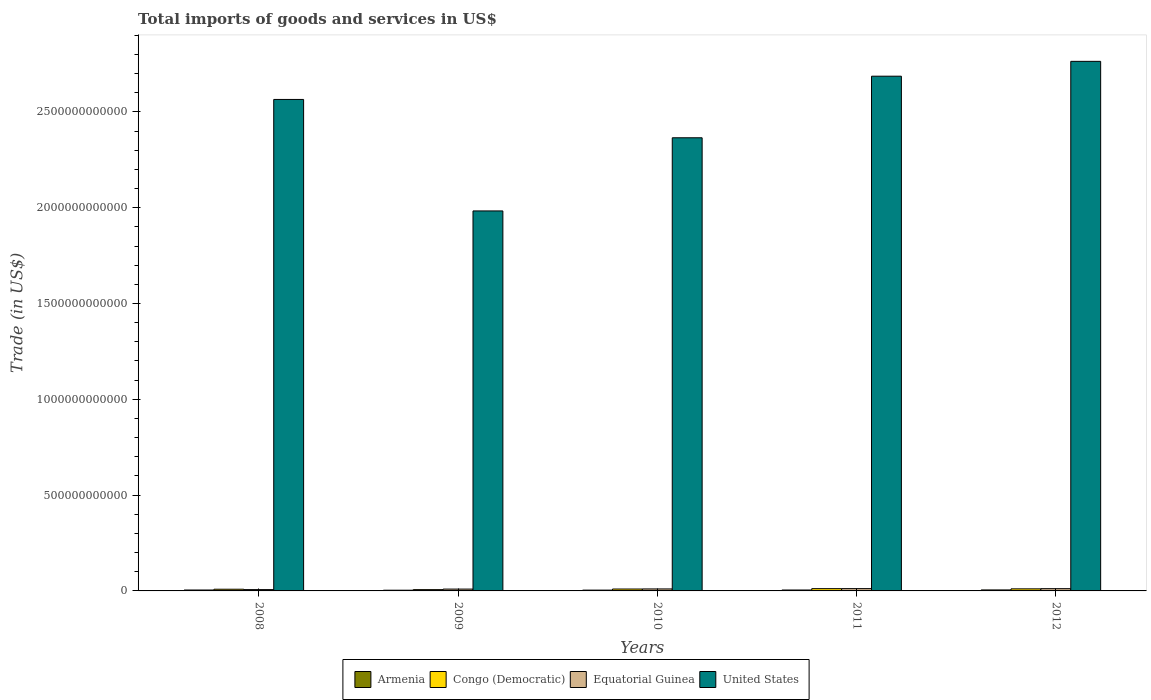How many groups of bars are there?
Offer a terse response. 5. Are the number of bars on each tick of the X-axis equal?
Keep it short and to the point. Yes. How many bars are there on the 2nd tick from the right?
Your response must be concise. 4. What is the total imports of goods and services in Congo (Democratic) in 2008?
Give a very brief answer. 8.85e+09. Across all years, what is the maximum total imports of goods and services in Equatorial Guinea?
Offer a very short reply. 1.20e+1. Across all years, what is the minimum total imports of goods and services in Equatorial Guinea?
Ensure brevity in your answer.  6.92e+09. In which year was the total imports of goods and services in Equatorial Guinea maximum?
Your answer should be very brief. 2011. What is the total total imports of goods and services in United States in the graph?
Ensure brevity in your answer.  1.24e+13. What is the difference between the total imports of goods and services in Armenia in 2011 and that in 2012?
Give a very brief answer. -3.37e+08. What is the difference between the total imports of goods and services in United States in 2011 and the total imports of goods and services in Congo (Democratic) in 2010?
Ensure brevity in your answer.  2.68e+12. What is the average total imports of goods and services in Congo (Democratic) per year?
Your answer should be very brief. 9.64e+09. In the year 2008, what is the difference between the total imports of goods and services in United States and total imports of goods and services in Armenia?
Offer a very short reply. 2.56e+12. What is the ratio of the total imports of goods and services in Congo (Democratic) in 2009 to that in 2012?
Keep it short and to the point. 0.62. Is the total imports of goods and services in Armenia in 2009 less than that in 2012?
Ensure brevity in your answer.  Yes. Is the difference between the total imports of goods and services in United States in 2008 and 2010 greater than the difference between the total imports of goods and services in Armenia in 2008 and 2010?
Offer a very short reply. Yes. What is the difference between the highest and the second highest total imports of goods and services in Congo (Democratic)?
Ensure brevity in your answer.  1.00e+09. What is the difference between the highest and the lowest total imports of goods and services in Congo (Democratic)?
Keep it short and to the point. 5.10e+09. In how many years, is the total imports of goods and services in United States greater than the average total imports of goods and services in United States taken over all years?
Provide a short and direct response. 3. Is the sum of the total imports of goods and services in Equatorial Guinea in 2008 and 2011 greater than the maximum total imports of goods and services in Armenia across all years?
Your answer should be very brief. Yes. What does the 4th bar from the left in 2012 represents?
Give a very brief answer. United States. Is it the case that in every year, the sum of the total imports of goods and services in Congo (Democratic) and total imports of goods and services in Armenia is greater than the total imports of goods and services in United States?
Ensure brevity in your answer.  No. How many years are there in the graph?
Your answer should be compact. 5. What is the difference between two consecutive major ticks on the Y-axis?
Provide a short and direct response. 5.00e+11. Does the graph contain grids?
Offer a very short reply. No. How are the legend labels stacked?
Your response must be concise. Horizontal. What is the title of the graph?
Give a very brief answer. Total imports of goods and services in US$. Does "Luxembourg" appear as one of the legend labels in the graph?
Your response must be concise. No. What is the label or title of the Y-axis?
Your answer should be compact. Trade (in US$). What is the Trade (in US$) of Armenia in 2008?
Your response must be concise. 4.74e+09. What is the Trade (in US$) of Congo (Democratic) in 2008?
Make the answer very short. 8.85e+09. What is the Trade (in US$) of Equatorial Guinea in 2008?
Give a very brief answer. 6.92e+09. What is the Trade (in US$) in United States in 2008?
Keep it short and to the point. 2.57e+12. What is the Trade (in US$) in Armenia in 2009?
Your answer should be compact. 3.72e+09. What is the Trade (in US$) in Congo (Democratic) in 2009?
Offer a terse response. 6.74e+09. What is the Trade (in US$) in Equatorial Guinea in 2009?
Provide a short and direct response. 9.54e+09. What is the Trade (in US$) of United States in 2009?
Make the answer very short. 1.98e+12. What is the Trade (in US$) of Armenia in 2010?
Keep it short and to the point. 4.20e+09. What is the Trade (in US$) of Congo (Democratic) in 2010?
Your answer should be compact. 9.94e+09. What is the Trade (in US$) in Equatorial Guinea in 2010?
Provide a succinct answer. 1.04e+1. What is the Trade (in US$) of United States in 2010?
Offer a terse response. 2.36e+12. What is the Trade (in US$) of Armenia in 2011?
Your answer should be compact. 4.80e+09. What is the Trade (in US$) of Congo (Democratic) in 2011?
Your answer should be compact. 1.18e+1. What is the Trade (in US$) of Equatorial Guinea in 2011?
Keep it short and to the point. 1.20e+1. What is the Trade (in US$) of United States in 2011?
Your answer should be compact. 2.69e+12. What is the Trade (in US$) in Armenia in 2012?
Keep it short and to the point. 5.14e+09. What is the Trade (in US$) in Congo (Democratic) in 2012?
Give a very brief answer. 1.08e+1. What is the Trade (in US$) in Equatorial Guinea in 2012?
Make the answer very short. 1.17e+1. What is the Trade (in US$) of United States in 2012?
Ensure brevity in your answer.  2.76e+12. Across all years, what is the maximum Trade (in US$) of Armenia?
Your answer should be compact. 5.14e+09. Across all years, what is the maximum Trade (in US$) of Congo (Democratic)?
Make the answer very short. 1.18e+1. Across all years, what is the maximum Trade (in US$) in Equatorial Guinea?
Your answer should be compact. 1.20e+1. Across all years, what is the maximum Trade (in US$) in United States?
Your answer should be compact. 2.76e+12. Across all years, what is the minimum Trade (in US$) in Armenia?
Give a very brief answer. 3.72e+09. Across all years, what is the minimum Trade (in US$) of Congo (Democratic)?
Your answer should be compact. 6.74e+09. Across all years, what is the minimum Trade (in US$) in Equatorial Guinea?
Keep it short and to the point. 6.92e+09. Across all years, what is the minimum Trade (in US$) of United States?
Your response must be concise. 1.98e+12. What is the total Trade (in US$) of Armenia in the graph?
Provide a succinct answer. 2.26e+1. What is the total Trade (in US$) of Congo (Democratic) in the graph?
Provide a succinct answer. 4.82e+1. What is the total Trade (in US$) in Equatorial Guinea in the graph?
Provide a succinct answer. 5.06e+1. What is the total Trade (in US$) in United States in the graph?
Keep it short and to the point. 1.24e+13. What is the difference between the Trade (in US$) of Armenia in 2008 and that in 2009?
Your answer should be very brief. 1.02e+09. What is the difference between the Trade (in US$) of Congo (Democratic) in 2008 and that in 2009?
Offer a terse response. 2.12e+09. What is the difference between the Trade (in US$) of Equatorial Guinea in 2008 and that in 2009?
Provide a succinct answer. -2.62e+09. What is the difference between the Trade (in US$) of United States in 2008 and that in 2009?
Provide a short and direct response. 5.82e+11. What is the difference between the Trade (in US$) of Armenia in 2008 and that in 2010?
Ensure brevity in your answer.  5.45e+08. What is the difference between the Trade (in US$) of Congo (Democratic) in 2008 and that in 2010?
Keep it short and to the point. -1.09e+09. What is the difference between the Trade (in US$) in Equatorial Guinea in 2008 and that in 2010?
Provide a succinct answer. -3.44e+09. What is the difference between the Trade (in US$) in United States in 2008 and that in 2010?
Your response must be concise. 2.00e+11. What is the difference between the Trade (in US$) of Armenia in 2008 and that in 2011?
Offer a very short reply. -6.14e+07. What is the difference between the Trade (in US$) in Congo (Democratic) in 2008 and that in 2011?
Give a very brief answer. -2.99e+09. What is the difference between the Trade (in US$) in Equatorial Guinea in 2008 and that in 2011?
Give a very brief answer. -5.09e+09. What is the difference between the Trade (in US$) in United States in 2008 and that in 2011?
Ensure brevity in your answer.  -1.21e+11. What is the difference between the Trade (in US$) in Armenia in 2008 and that in 2012?
Give a very brief answer. -3.98e+08. What is the difference between the Trade (in US$) of Congo (Democratic) in 2008 and that in 2012?
Your response must be concise. -1.99e+09. What is the difference between the Trade (in US$) in Equatorial Guinea in 2008 and that in 2012?
Your answer should be compact. -4.82e+09. What is the difference between the Trade (in US$) in United States in 2008 and that in 2012?
Your answer should be very brief. -1.99e+11. What is the difference between the Trade (in US$) of Armenia in 2009 and that in 2010?
Provide a short and direct response. -4.78e+08. What is the difference between the Trade (in US$) of Congo (Democratic) in 2009 and that in 2010?
Provide a short and direct response. -3.20e+09. What is the difference between the Trade (in US$) in Equatorial Guinea in 2009 and that in 2010?
Your answer should be very brief. -8.16e+08. What is the difference between the Trade (in US$) in United States in 2009 and that in 2010?
Offer a very short reply. -3.82e+11. What is the difference between the Trade (in US$) of Armenia in 2009 and that in 2011?
Provide a succinct answer. -1.08e+09. What is the difference between the Trade (in US$) of Congo (Democratic) in 2009 and that in 2011?
Your response must be concise. -5.10e+09. What is the difference between the Trade (in US$) in Equatorial Guinea in 2009 and that in 2011?
Ensure brevity in your answer.  -2.47e+09. What is the difference between the Trade (in US$) of United States in 2009 and that in 2011?
Offer a very short reply. -7.03e+11. What is the difference between the Trade (in US$) in Armenia in 2009 and that in 2012?
Offer a very short reply. -1.42e+09. What is the difference between the Trade (in US$) of Congo (Democratic) in 2009 and that in 2012?
Your answer should be very brief. -4.10e+09. What is the difference between the Trade (in US$) in Equatorial Guinea in 2009 and that in 2012?
Offer a very short reply. -2.20e+09. What is the difference between the Trade (in US$) in United States in 2009 and that in 2012?
Offer a terse response. -7.81e+11. What is the difference between the Trade (in US$) in Armenia in 2010 and that in 2011?
Your answer should be very brief. -6.06e+08. What is the difference between the Trade (in US$) of Congo (Democratic) in 2010 and that in 2011?
Your answer should be compact. -1.90e+09. What is the difference between the Trade (in US$) in Equatorial Guinea in 2010 and that in 2011?
Give a very brief answer. -1.65e+09. What is the difference between the Trade (in US$) in United States in 2010 and that in 2011?
Give a very brief answer. -3.21e+11. What is the difference between the Trade (in US$) of Armenia in 2010 and that in 2012?
Keep it short and to the point. -9.43e+08. What is the difference between the Trade (in US$) of Congo (Democratic) in 2010 and that in 2012?
Ensure brevity in your answer.  -8.99e+08. What is the difference between the Trade (in US$) of Equatorial Guinea in 2010 and that in 2012?
Your response must be concise. -1.39e+09. What is the difference between the Trade (in US$) of United States in 2010 and that in 2012?
Offer a terse response. -3.99e+11. What is the difference between the Trade (in US$) of Armenia in 2011 and that in 2012?
Provide a succinct answer. -3.37e+08. What is the difference between the Trade (in US$) of Congo (Democratic) in 2011 and that in 2012?
Your response must be concise. 1.00e+09. What is the difference between the Trade (in US$) in Equatorial Guinea in 2011 and that in 2012?
Your answer should be very brief. 2.66e+08. What is the difference between the Trade (in US$) of United States in 2011 and that in 2012?
Offer a terse response. -7.75e+1. What is the difference between the Trade (in US$) of Armenia in 2008 and the Trade (in US$) of Congo (Democratic) in 2009?
Provide a succinct answer. -2.00e+09. What is the difference between the Trade (in US$) in Armenia in 2008 and the Trade (in US$) in Equatorial Guinea in 2009?
Provide a succinct answer. -4.80e+09. What is the difference between the Trade (in US$) of Armenia in 2008 and the Trade (in US$) of United States in 2009?
Ensure brevity in your answer.  -1.98e+12. What is the difference between the Trade (in US$) of Congo (Democratic) in 2008 and the Trade (in US$) of Equatorial Guinea in 2009?
Provide a short and direct response. -6.85e+08. What is the difference between the Trade (in US$) of Congo (Democratic) in 2008 and the Trade (in US$) of United States in 2009?
Make the answer very short. -1.97e+12. What is the difference between the Trade (in US$) of Equatorial Guinea in 2008 and the Trade (in US$) of United States in 2009?
Give a very brief answer. -1.98e+12. What is the difference between the Trade (in US$) of Armenia in 2008 and the Trade (in US$) of Congo (Democratic) in 2010?
Provide a short and direct response. -5.20e+09. What is the difference between the Trade (in US$) in Armenia in 2008 and the Trade (in US$) in Equatorial Guinea in 2010?
Offer a terse response. -5.61e+09. What is the difference between the Trade (in US$) in Armenia in 2008 and the Trade (in US$) in United States in 2010?
Your answer should be very brief. -2.36e+12. What is the difference between the Trade (in US$) of Congo (Democratic) in 2008 and the Trade (in US$) of Equatorial Guinea in 2010?
Your answer should be very brief. -1.50e+09. What is the difference between the Trade (in US$) in Congo (Democratic) in 2008 and the Trade (in US$) in United States in 2010?
Offer a terse response. -2.36e+12. What is the difference between the Trade (in US$) of Equatorial Guinea in 2008 and the Trade (in US$) of United States in 2010?
Offer a very short reply. -2.36e+12. What is the difference between the Trade (in US$) of Armenia in 2008 and the Trade (in US$) of Congo (Democratic) in 2011?
Ensure brevity in your answer.  -7.10e+09. What is the difference between the Trade (in US$) in Armenia in 2008 and the Trade (in US$) in Equatorial Guinea in 2011?
Provide a short and direct response. -7.27e+09. What is the difference between the Trade (in US$) of Armenia in 2008 and the Trade (in US$) of United States in 2011?
Keep it short and to the point. -2.68e+12. What is the difference between the Trade (in US$) of Congo (Democratic) in 2008 and the Trade (in US$) of Equatorial Guinea in 2011?
Offer a very short reply. -3.16e+09. What is the difference between the Trade (in US$) in Congo (Democratic) in 2008 and the Trade (in US$) in United States in 2011?
Ensure brevity in your answer.  -2.68e+12. What is the difference between the Trade (in US$) of Equatorial Guinea in 2008 and the Trade (in US$) of United States in 2011?
Your answer should be compact. -2.68e+12. What is the difference between the Trade (in US$) of Armenia in 2008 and the Trade (in US$) of Congo (Democratic) in 2012?
Offer a very short reply. -6.10e+09. What is the difference between the Trade (in US$) in Armenia in 2008 and the Trade (in US$) in Equatorial Guinea in 2012?
Provide a short and direct response. -7.00e+09. What is the difference between the Trade (in US$) in Armenia in 2008 and the Trade (in US$) in United States in 2012?
Ensure brevity in your answer.  -2.76e+12. What is the difference between the Trade (in US$) of Congo (Democratic) in 2008 and the Trade (in US$) of Equatorial Guinea in 2012?
Make the answer very short. -2.89e+09. What is the difference between the Trade (in US$) of Congo (Democratic) in 2008 and the Trade (in US$) of United States in 2012?
Your response must be concise. -2.75e+12. What is the difference between the Trade (in US$) in Equatorial Guinea in 2008 and the Trade (in US$) in United States in 2012?
Provide a succinct answer. -2.76e+12. What is the difference between the Trade (in US$) in Armenia in 2009 and the Trade (in US$) in Congo (Democratic) in 2010?
Provide a short and direct response. -6.22e+09. What is the difference between the Trade (in US$) in Armenia in 2009 and the Trade (in US$) in Equatorial Guinea in 2010?
Make the answer very short. -6.64e+09. What is the difference between the Trade (in US$) of Armenia in 2009 and the Trade (in US$) of United States in 2010?
Make the answer very short. -2.36e+12. What is the difference between the Trade (in US$) of Congo (Democratic) in 2009 and the Trade (in US$) of Equatorial Guinea in 2010?
Make the answer very short. -3.62e+09. What is the difference between the Trade (in US$) in Congo (Democratic) in 2009 and the Trade (in US$) in United States in 2010?
Ensure brevity in your answer.  -2.36e+12. What is the difference between the Trade (in US$) of Equatorial Guinea in 2009 and the Trade (in US$) of United States in 2010?
Give a very brief answer. -2.36e+12. What is the difference between the Trade (in US$) of Armenia in 2009 and the Trade (in US$) of Congo (Democratic) in 2011?
Your answer should be very brief. -8.12e+09. What is the difference between the Trade (in US$) in Armenia in 2009 and the Trade (in US$) in Equatorial Guinea in 2011?
Ensure brevity in your answer.  -8.29e+09. What is the difference between the Trade (in US$) in Armenia in 2009 and the Trade (in US$) in United States in 2011?
Offer a very short reply. -2.68e+12. What is the difference between the Trade (in US$) of Congo (Democratic) in 2009 and the Trade (in US$) of Equatorial Guinea in 2011?
Offer a terse response. -5.27e+09. What is the difference between the Trade (in US$) of Congo (Democratic) in 2009 and the Trade (in US$) of United States in 2011?
Keep it short and to the point. -2.68e+12. What is the difference between the Trade (in US$) in Equatorial Guinea in 2009 and the Trade (in US$) in United States in 2011?
Your response must be concise. -2.68e+12. What is the difference between the Trade (in US$) in Armenia in 2009 and the Trade (in US$) in Congo (Democratic) in 2012?
Your answer should be compact. -7.12e+09. What is the difference between the Trade (in US$) of Armenia in 2009 and the Trade (in US$) of Equatorial Guinea in 2012?
Provide a succinct answer. -8.02e+09. What is the difference between the Trade (in US$) in Armenia in 2009 and the Trade (in US$) in United States in 2012?
Offer a very short reply. -2.76e+12. What is the difference between the Trade (in US$) of Congo (Democratic) in 2009 and the Trade (in US$) of Equatorial Guinea in 2012?
Keep it short and to the point. -5.01e+09. What is the difference between the Trade (in US$) in Congo (Democratic) in 2009 and the Trade (in US$) in United States in 2012?
Your response must be concise. -2.76e+12. What is the difference between the Trade (in US$) of Equatorial Guinea in 2009 and the Trade (in US$) of United States in 2012?
Your answer should be very brief. -2.75e+12. What is the difference between the Trade (in US$) of Armenia in 2010 and the Trade (in US$) of Congo (Democratic) in 2011?
Make the answer very short. -7.64e+09. What is the difference between the Trade (in US$) in Armenia in 2010 and the Trade (in US$) in Equatorial Guinea in 2011?
Provide a succinct answer. -7.81e+09. What is the difference between the Trade (in US$) of Armenia in 2010 and the Trade (in US$) of United States in 2011?
Your answer should be very brief. -2.68e+12. What is the difference between the Trade (in US$) in Congo (Democratic) in 2010 and the Trade (in US$) in Equatorial Guinea in 2011?
Give a very brief answer. -2.07e+09. What is the difference between the Trade (in US$) in Congo (Democratic) in 2010 and the Trade (in US$) in United States in 2011?
Your answer should be very brief. -2.68e+12. What is the difference between the Trade (in US$) of Equatorial Guinea in 2010 and the Trade (in US$) of United States in 2011?
Your response must be concise. -2.68e+12. What is the difference between the Trade (in US$) of Armenia in 2010 and the Trade (in US$) of Congo (Democratic) in 2012?
Provide a succinct answer. -6.64e+09. What is the difference between the Trade (in US$) in Armenia in 2010 and the Trade (in US$) in Equatorial Guinea in 2012?
Offer a terse response. -7.55e+09. What is the difference between the Trade (in US$) of Armenia in 2010 and the Trade (in US$) of United States in 2012?
Ensure brevity in your answer.  -2.76e+12. What is the difference between the Trade (in US$) of Congo (Democratic) in 2010 and the Trade (in US$) of Equatorial Guinea in 2012?
Offer a very short reply. -1.80e+09. What is the difference between the Trade (in US$) in Congo (Democratic) in 2010 and the Trade (in US$) in United States in 2012?
Keep it short and to the point. -2.75e+12. What is the difference between the Trade (in US$) in Equatorial Guinea in 2010 and the Trade (in US$) in United States in 2012?
Ensure brevity in your answer.  -2.75e+12. What is the difference between the Trade (in US$) of Armenia in 2011 and the Trade (in US$) of Congo (Democratic) in 2012?
Provide a succinct answer. -6.04e+09. What is the difference between the Trade (in US$) in Armenia in 2011 and the Trade (in US$) in Equatorial Guinea in 2012?
Ensure brevity in your answer.  -6.94e+09. What is the difference between the Trade (in US$) in Armenia in 2011 and the Trade (in US$) in United States in 2012?
Offer a terse response. -2.76e+12. What is the difference between the Trade (in US$) in Congo (Democratic) in 2011 and the Trade (in US$) in Equatorial Guinea in 2012?
Your answer should be very brief. 9.64e+07. What is the difference between the Trade (in US$) of Congo (Democratic) in 2011 and the Trade (in US$) of United States in 2012?
Provide a short and direct response. -2.75e+12. What is the difference between the Trade (in US$) in Equatorial Guinea in 2011 and the Trade (in US$) in United States in 2012?
Keep it short and to the point. -2.75e+12. What is the average Trade (in US$) in Armenia per year?
Ensure brevity in your answer.  4.52e+09. What is the average Trade (in US$) in Congo (Democratic) per year?
Your answer should be compact. 9.64e+09. What is the average Trade (in US$) in Equatorial Guinea per year?
Provide a succinct answer. 1.01e+1. What is the average Trade (in US$) of United States per year?
Make the answer very short. 2.47e+12. In the year 2008, what is the difference between the Trade (in US$) in Armenia and Trade (in US$) in Congo (Democratic)?
Give a very brief answer. -4.11e+09. In the year 2008, what is the difference between the Trade (in US$) of Armenia and Trade (in US$) of Equatorial Guinea?
Offer a very short reply. -2.18e+09. In the year 2008, what is the difference between the Trade (in US$) of Armenia and Trade (in US$) of United States?
Provide a short and direct response. -2.56e+12. In the year 2008, what is the difference between the Trade (in US$) of Congo (Democratic) and Trade (in US$) of Equatorial Guinea?
Offer a terse response. 1.94e+09. In the year 2008, what is the difference between the Trade (in US$) of Congo (Democratic) and Trade (in US$) of United States?
Provide a succinct answer. -2.56e+12. In the year 2008, what is the difference between the Trade (in US$) in Equatorial Guinea and Trade (in US$) in United States?
Give a very brief answer. -2.56e+12. In the year 2009, what is the difference between the Trade (in US$) of Armenia and Trade (in US$) of Congo (Democratic)?
Your answer should be very brief. -3.02e+09. In the year 2009, what is the difference between the Trade (in US$) in Armenia and Trade (in US$) in Equatorial Guinea?
Make the answer very short. -5.82e+09. In the year 2009, what is the difference between the Trade (in US$) in Armenia and Trade (in US$) in United States?
Your answer should be very brief. -1.98e+12. In the year 2009, what is the difference between the Trade (in US$) in Congo (Democratic) and Trade (in US$) in Equatorial Guinea?
Provide a succinct answer. -2.80e+09. In the year 2009, what is the difference between the Trade (in US$) of Congo (Democratic) and Trade (in US$) of United States?
Ensure brevity in your answer.  -1.98e+12. In the year 2009, what is the difference between the Trade (in US$) in Equatorial Guinea and Trade (in US$) in United States?
Your answer should be very brief. -1.97e+12. In the year 2010, what is the difference between the Trade (in US$) of Armenia and Trade (in US$) of Congo (Democratic)?
Your response must be concise. -5.74e+09. In the year 2010, what is the difference between the Trade (in US$) in Armenia and Trade (in US$) in Equatorial Guinea?
Provide a succinct answer. -6.16e+09. In the year 2010, what is the difference between the Trade (in US$) in Armenia and Trade (in US$) in United States?
Provide a short and direct response. -2.36e+12. In the year 2010, what is the difference between the Trade (in US$) in Congo (Democratic) and Trade (in US$) in Equatorial Guinea?
Your answer should be compact. -4.15e+08. In the year 2010, what is the difference between the Trade (in US$) of Congo (Democratic) and Trade (in US$) of United States?
Your answer should be compact. -2.36e+12. In the year 2010, what is the difference between the Trade (in US$) in Equatorial Guinea and Trade (in US$) in United States?
Your answer should be compact. -2.35e+12. In the year 2011, what is the difference between the Trade (in US$) in Armenia and Trade (in US$) in Congo (Democratic)?
Make the answer very short. -7.04e+09. In the year 2011, what is the difference between the Trade (in US$) in Armenia and Trade (in US$) in Equatorial Guinea?
Your answer should be very brief. -7.21e+09. In the year 2011, what is the difference between the Trade (in US$) in Armenia and Trade (in US$) in United States?
Provide a succinct answer. -2.68e+12. In the year 2011, what is the difference between the Trade (in US$) of Congo (Democratic) and Trade (in US$) of Equatorial Guinea?
Make the answer very short. -1.70e+08. In the year 2011, what is the difference between the Trade (in US$) in Congo (Democratic) and Trade (in US$) in United States?
Give a very brief answer. -2.67e+12. In the year 2011, what is the difference between the Trade (in US$) in Equatorial Guinea and Trade (in US$) in United States?
Ensure brevity in your answer.  -2.67e+12. In the year 2012, what is the difference between the Trade (in US$) in Armenia and Trade (in US$) in Congo (Democratic)?
Give a very brief answer. -5.70e+09. In the year 2012, what is the difference between the Trade (in US$) in Armenia and Trade (in US$) in Equatorial Guinea?
Offer a very short reply. -6.60e+09. In the year 2012, what is the difference between the Trade (in US$) of Armenia and Trade (in US$) of United States?
Make the answer very short. -2.76e+12. In the year 2012, what is the difference between the Trade (in US$) in Congo (Democratic) and Trade (in US$) in Equatorial Guinea?
Offer a very short reply. -9.03e+08. In the year 2012, what is the difference between the Trade (in US$) in Congo (Democratic) and Trade (in US$) in United States?
Make the answer very short. -2.75e+12. In the year 2012, what is the difference between the Trade (in US$) in Equatorial Guinea and Trade (in US$) in United States?
Your response must be concise. -2.75e+12. What is the ratio of the Trade (in US$) in Armenia in 2008 to that in 2009?
Provide a succinct answer. 1.27. What is the ratio of the Trade (in US$) of Congo (Democratic) in 2008 to that in 2009?
Offer a very short reply. 1.31. What is the ratio of the Trade (in US$) in Equatorial Guinea in 2008 to that in 2009?
Your response must be concise. 0.73. What is the ratio of the Trade (in US$) of United States in 2008 to that in 2009?
Offer a terse response. 1.29. What is the ratio of the Trade (in US$) of Armenia in 2008 to that in 2010?
Provide a succinct answer. 1.13. What is the ratio of the Trade (in US$) in Congo (Democratic) in 2008 to that in 2010?
Provide a succinct answer. 0.89. What is the ratio of the Trade (in US$) in Equatorial Guinea in 2008 to that in 2010?
Offer a terse response. 0.67. What is the ratio of the Trade (in US$) of United States in 2008 to that in 2010?
Offer a terse response. 1.08. What is the ratio of the Trade (in US$) of Armenia in 2008 to that in 2011?
Your answer should be very brief. 0.99. What is the ratio of the Trade (in US$) in Congo (Democratic) in 2008 to that in 2011?
Your answer should be very brief. 0.75. What is the ratio of the Trade (in US$) of Equatorial Guinea in 2008 to that in 2011?
Your answer should be compact. 0.58. What is the ratio of the Trade (in US$) of United States in 2008 to that in 2011?
Keep it short and to the point. 0.95. What is the ratio of the Trade (in US$) in Armenia in 2008 to that in 2012?
Give a very brief answer. 0.92. What is the ratio of the Trade (in US$) in Congo (Democratic) in 2008 to that in 2012?
Offer a terse response. 0.82. What is the ratio of the Trade (in US$) in Equatorial Guinea in 2008 to that in 2012?
Keep it short and to the point. 0.59. What is the ratio of the Trade (in US$) of United States in 2008 to that in 2012?
Your answer should be compact. 0.93. What is the ratio of the Trade (in US$) in Armenia in 2009 to that in 2010?
Make the answer very short. 0.89. What is the ratio of the Trade (in US$) in Congo (Democratic) in 2009 to that in 2010?
Provide a succinct answer. 0.68. What is the ratio of the Trade (in US$) in Equatorial Guinea in 2009 to that in 2010?
Your answer should be compact. 0.92. What is the ratio of the Trade (in US$) in United States in 2009 to that in 2010?
Your answer should be very brief. 0.84. What is the ratio of the Trade (in US$) of Armenia in 2009 to that in 2011?
Offer a terse response. 0.77. What is the ratio of the Trade (in US$) of Congo (Democratic) in 2009 to that in 2011?
Provide a succinct answer. 0.57. What is the ratio of the Trade (in US$) of Equatorial Guinea in 2009 to that in 2011?
Your answer should be compact. 0.79. What is the ratio of the Trade (in US$) in United States in 2009 to that in 2011?
Provide a succinct answer. 0.74. What is the ratio of the Trade (in US$) in Armenia in 2009 to that in 2012?
Your answer should be compact. 0.72. What is the ratio of the Trade (in US$) of Congo (Democratic) in 2009 to that in 2012?
Provide a short and direct response. 0.62. What is the ratio of the Trade (in US$) in Equatorial Guinea in 2009 to that in 2012?
Give a very brief answer. 0.81. What is the ratio of the Trade (in US$) in United States in 2009 to that in 2012?
Provide a succinct answer. 0.72. What is the ratio of the Trade (in US$) in Armenia in 2010 to that in 2011?
Ensure brevity in your answer.  0.87. What is the ratio of the Trade (in US$) of Congo (Democratic) in 2010 to that in 2011?
Make the answer very short. 0.84. What is the ratio of the Trade (in US$) of Equatorial Guinea in 2010 to that in 2011?
Offer a very short reply. 0.86. What is the ratio of the Trade (in US$) in United States in 2010 to that in 2011?
Your answer should be very brief. 0.88. What is the ratio of the Trade (in US$) in Armenia in 2010 to that in 2012?
Ensure brevity in your answer.  0.82. What is the ratio of the Trade (in US$) of Congo (Democratic) in 2010 to that in 2012?
Provide a succinct answer. 0.92. What is the ratio of the Trade (in US$) in Equatorial Guinea in 2010 to that in 2012?
Offer a very short reply. 0.88. What is the ratio of the Trade (in US$) of United States in 2010 to that in 2012?
Offer a terse response. 0.86. What is the ratio of the Trade (in US$) in Armenia in 2011 to that in 2012?
Make the answer very short. 0.93. What is the ratio of the Trade (in US$) in Congo (Democratic) in 2011 to that in 2012?
Offer a very short reply. 1.09. What is the ratio of the Trade (in US$) in Equatorial Guinea in 2011 to that in 2012?
Keep it short and to the point. 1.02. What is the ratio of the Trade (in US$) of United States in 2011 to that in 2012?
Your response must be concise. 0.97. What is the difference between the highest and the second highest Trade (in US$) of Armenia?
Your answer should be very brief. 3.37e+08. What is the difference between the highest and the second highest Trade (in US$) of Congo (Democratic)?
Make the answer very short. 1.00e+09. What is the difference between the highest and the second highest Trade (in US$) in Equatorial Guinea?
Your answer should be very brief. 2.66e+08. What is the difference between the highest and the second highest Trade (in US$) of United States?
Make the answer very short. 7.75e+1. What is the difference between the highest and the lowest Trade (in US$) of Armenia?
Provide a succinct answer. 1.42e+09. What is the difference between the highest and the lowest Trade (in US$) in Congo (Democratic)?
Offer a very short reply. 5.10e+09. What is the difference between the highest and the lowest Trade (in US$) of Equatorial Guinea?
Offer a terse response. 5.09e+09. What is the difference between the highest and the lowest Trade (in US$) of United States?
Your response must be concise. 7.81e+11. 